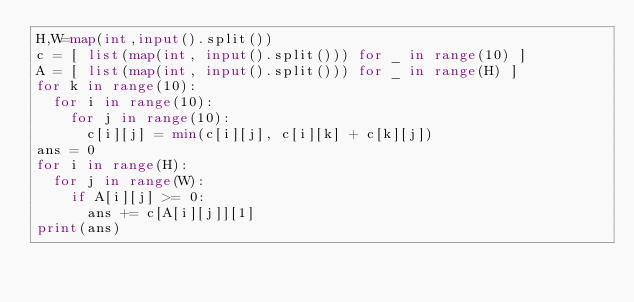Convert code to text. <code><loc_0><loc_0><loc_500><loc_500><_Python_>H,W=map(int,input().split())
c = [ list(map(int, input().split())) for _ in range(10) ]
A = [ list(map(int, input().split())) for _ in range(H) ]
for k in range(10):
  for i in range(10):
    for j in range(10):
      c[i][j] = min(c[i][j], c[i][k] + c[k][j])
ans = 0
for i in range(H):
  for j in range(W):
    if A[i][j] >= 0:
      ans += c[A[i][j]][1]
print(ans)
</code> 